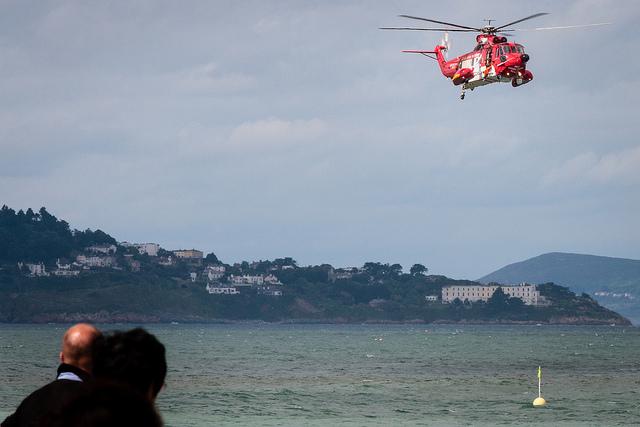Is there a kite in the sky?
Concise answer only. No. What is the helicopter flying over?
Write a very short answer. Water. How high is the helicopter?
Keep it brief. Low. What is in the air?
Answer briefly. Helicopter. Is this a rescue?
Keep it brief. Yes. Is there any relation to the man and the red object?
Keep it brief. No. 